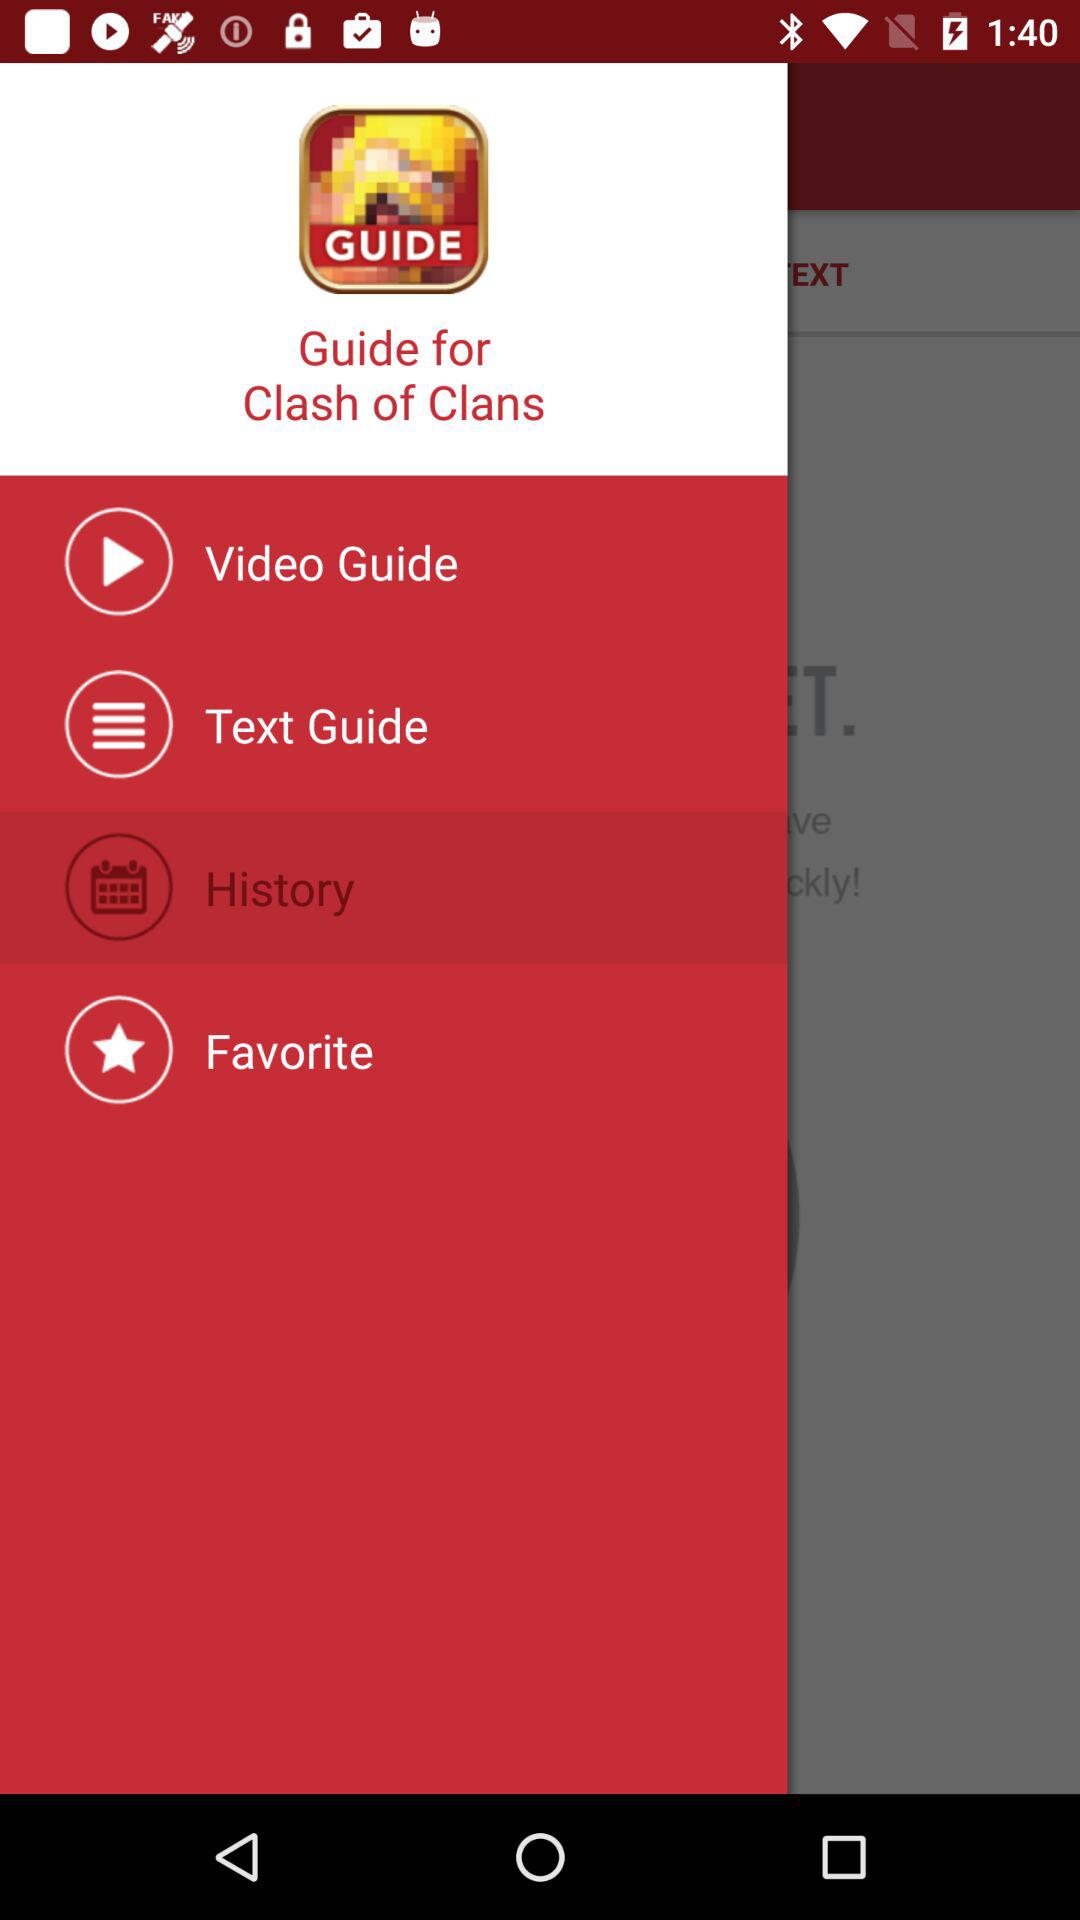What is the application name? The application name is "Guide for Clash of Clans". 